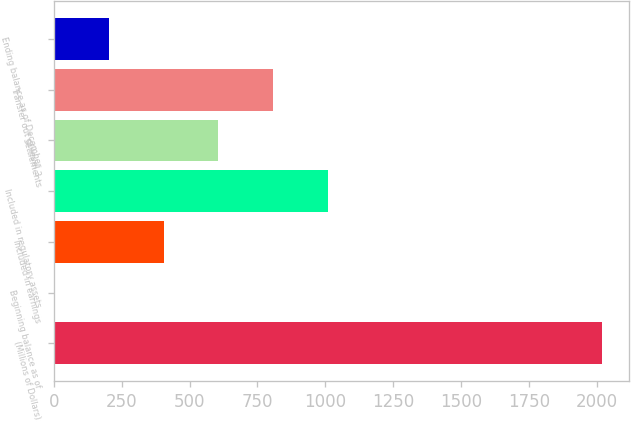Convert chart to OTSL. <chart><loc_0><loc_0><loc_500><loc_500><bar_chart><fcel>(Millions of Dollars)<fcel>Beginning balance as of<fcel>Included in earnings<fcel>Included in regulatory assets<fcel>Settlements<fcel>Transfer out of level 3<fcel>Ending balance as of December<nl><fcel>2017<fcel>1<fcel>404.2<fcel>1009<fcel>605.8<fcel>807.4<fcel>202.6<nl></chart> 